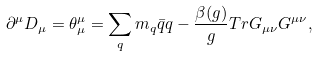<formula> <loc_0><loc_0><loc_500><loc_500>\partial ^ { \mu } D _ { \mu } = \theta ^ { \mu } _ { \mu } = \sum _ { q } m _ { q } \bar { q } q - \frac { \beta ( g ) } { g } T r G _ { \mu \nu } G ^ { \mu \nu } ,</formula> 